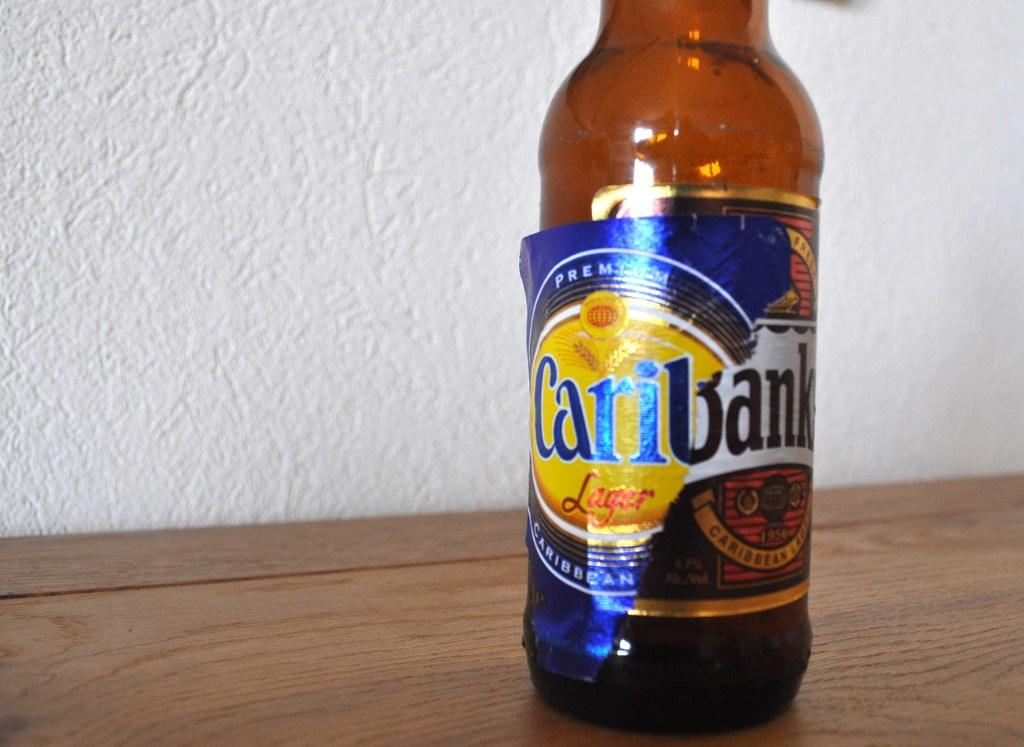<image>
Create a compact narrative representing the image presented. Bottle of Caribank sits on a wooden table 